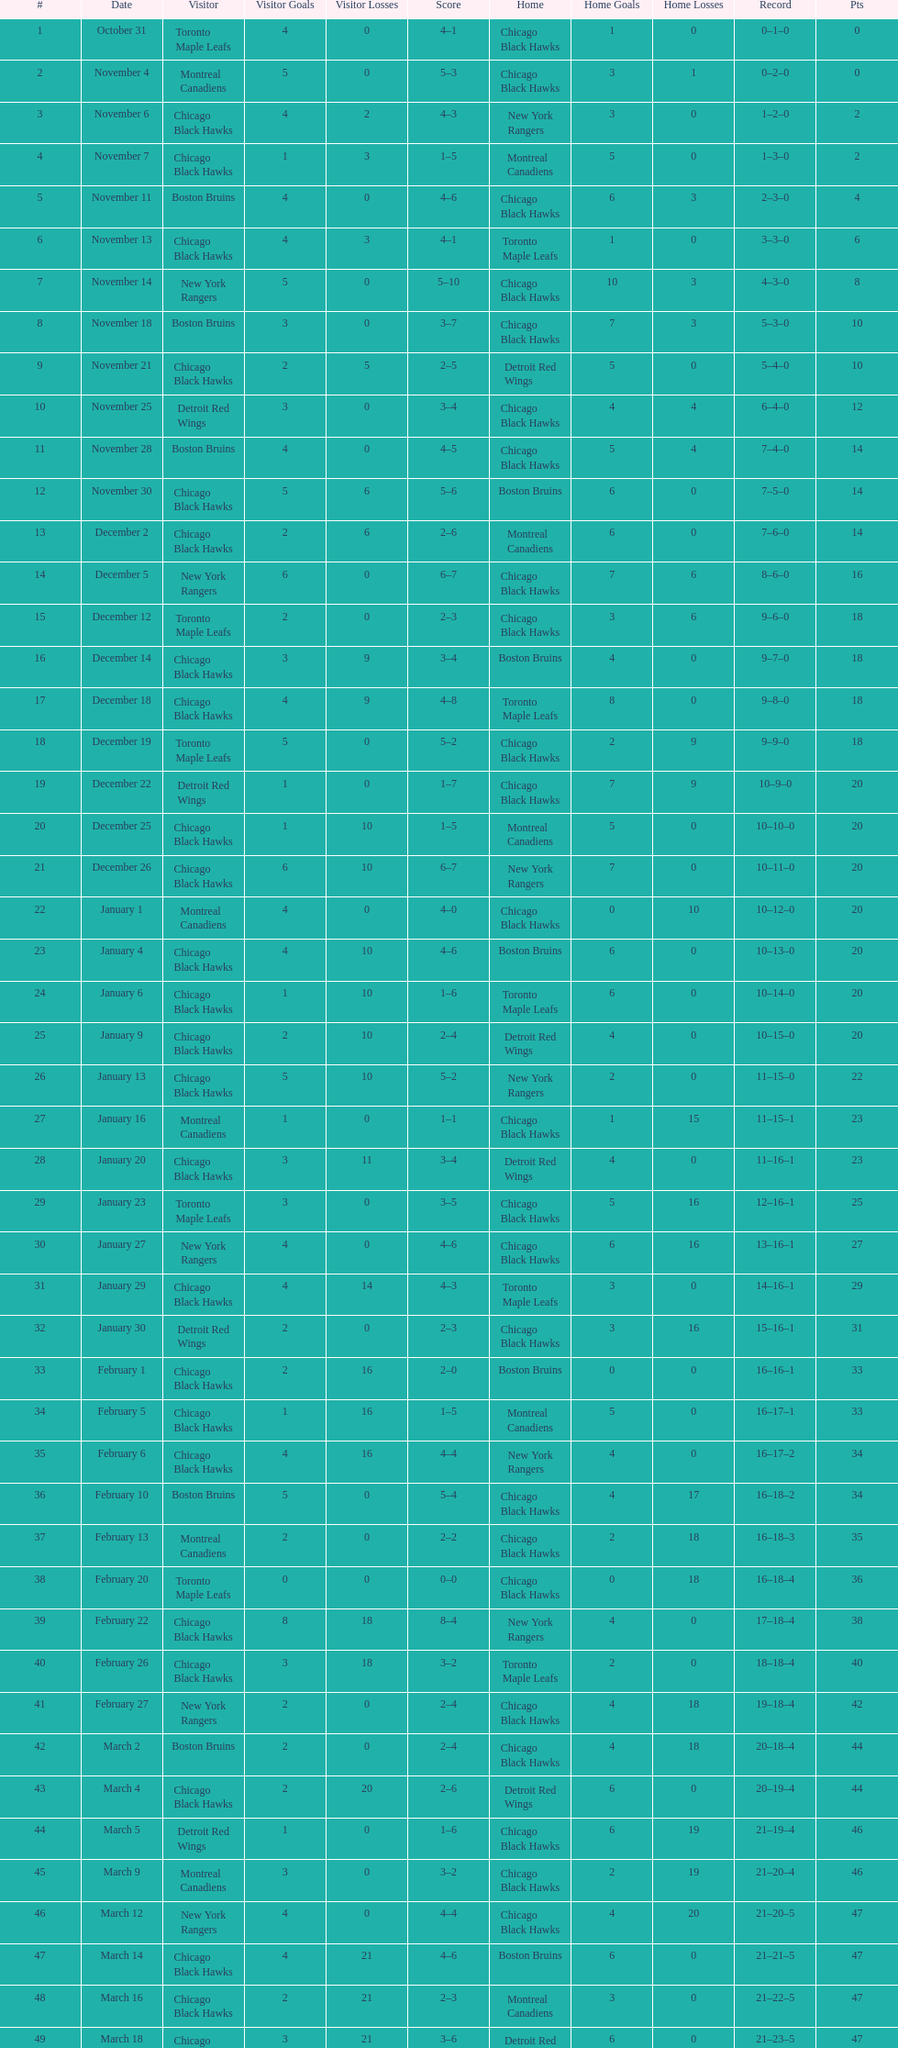Who was the next team that the boston bruins played after november 11? Chicago Black Hawks. 